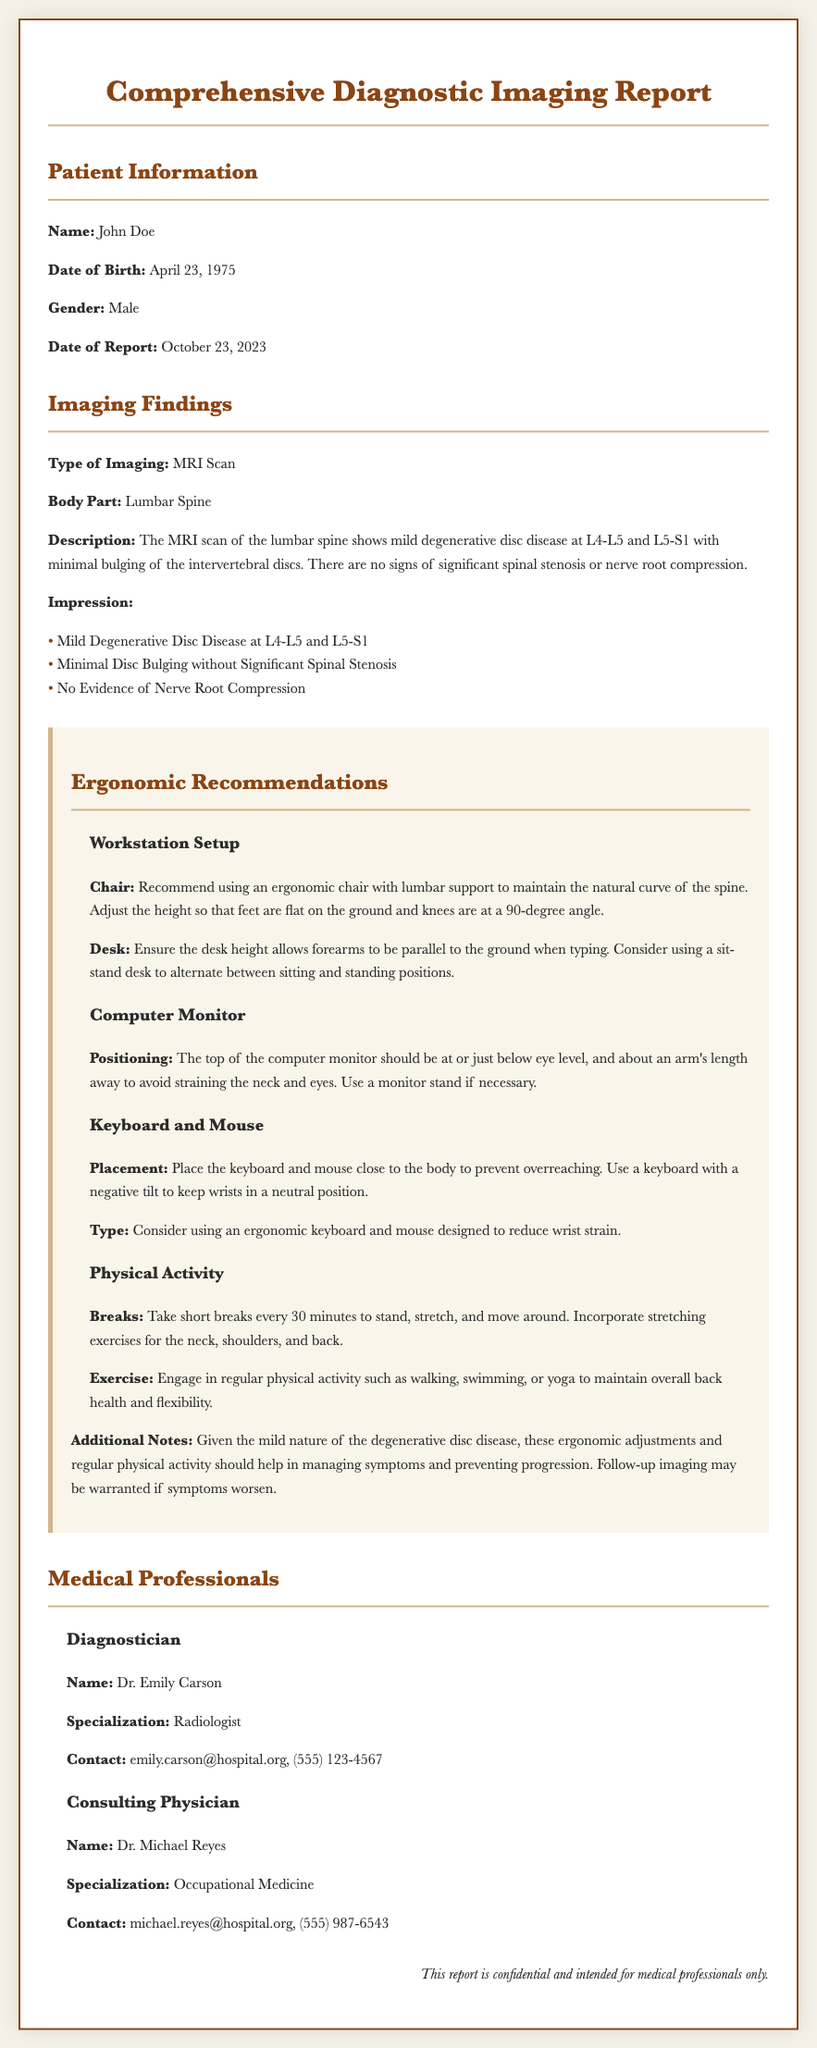What is the patient's name? The patient's name is provided in the "Patient Information" section of the report.
Answer: John Doe What type of imaging was conducted? The type of imaging is specified in the "Imaging Findings" section.
Answer: MRI Scan What body part was examined in the report? The body part examined is mentioned in the "Imaging Findings" section.
Answer: Lumbar Spine Who is the consulting physician? The name of the consulting physician is located in the "Medical Professionals" section.
Answer: Dr. Michael Reyes What is the recommendation for the chair? The recommendation for the chair is detailed in the "Ergonomic Recommendations" section under "Workstation Setup".
Answer: Ergonomic chair with lumbar support How often should breaks be taken according to the recommendations? The frequency of breaks is specified in the "Physical Activity" subsection of "Ergonomic Recommendations".
Answer: Every 30 minutes What is the impression of the MRI findings? The impression can be found in the "Imaging Findings" section as listed points.
Answer: Mild Degenerative Disc Disease at L4-L5 and L5-S1 What should the height of the desk allow? This requirement is outlined in the "Workstation Setup" section of the recommendations.
Answer: Forearms to be parallel to the ground when typing What is the date of the report? The date of the report is listed in the "Patient Information" section.
Answer: October 23, 2023 